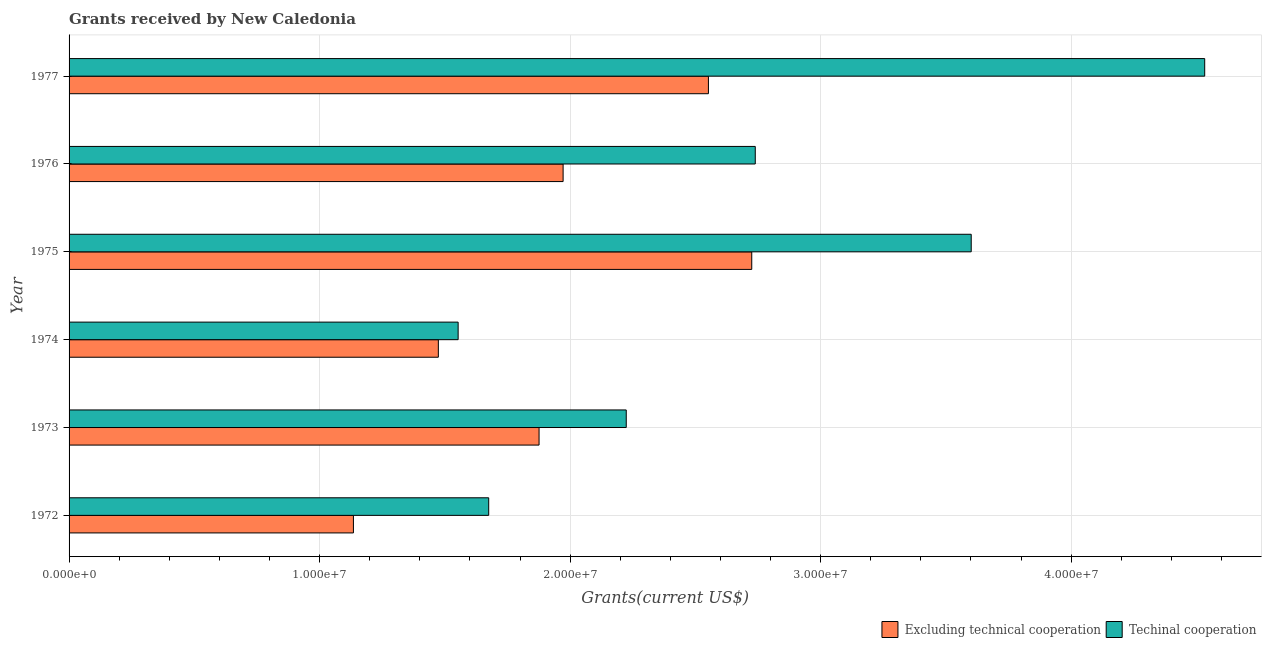How many groups of bars are there?
Your answer should be very brief. 6. Are the number of bars per tick equal to the number of legend labels?
Offer a very short reply. Yes. How many bars are there on the 3rd tick from the top?
Offer a terse response. 2. What is the label of the 4th group of bars from the top?
Your answer should be very brief. 1974. What is the amount of grants received(excluding technical cooperation) in 1972?
Your response must be concise. 1.14e+07. Across all years, what is the maximum amount of grants received(excluding technical cooperation)?
Make the answer very short. 2.72e+07. Across all years, what is the minimum amount of grants received(excluding technical cooperation)?
Your answer should be very brief. 1.14e+07. In which year was the amount of grants received(excluding technical cooperation) maximum?
Your answer should be compact. 1975. What is the total amount of grants received(including technical cooperation) in the graph?
Offer a very short reply. 1.63e+08. What is the difference between the amount of grants received(including technical cooperation) in 1973 and that in 1975?
Make the answer very short. -1.38e+07. What is the difference between the amount of grants received(excluding technical cooperation) in 1975 and the amount of grants received(including technical cooperation) in 1976?
Your response must be concise. -1.40e+05. What is the average amount of grants received(excluding technical cooperation) per year?
Your answer should be compact. 1.96e+07. In the year 1973, what is the difference between the amount of grants received(excluding technical cooperation) and amount of grants received(including technical cooperation)?
Give a very brief answer. -3.48e+06. In how many years, is the amount of grants received(excluding technical cooperation) greater than 2000000 US$?
Offer a terse response. 6. What is the ratio of the amount of grants received(including technical cooperation) in 1972 to that in 1974?
Make the answer very short. 1.08. Is the amount of grants received(excluding technical cooperation) in 1973 less than that in 1977?
Your answer should be very brief. Yes. What is the difference between the highest and the second highest amount of grants received(including technical cooperation)?
Offer a terse response. 9.32e+06. What is the difference between the highest and the lowest amount of grants received(excluding technical cooperation)?
Your response must be concise. 1.59e+07. Is the sum of the amount of grants received(excluding technical cooperation) in 1973 and 1975 greater than the maximum amount of grants received(including technical cooperation) across all years?
Provide a succinct answer. Yes. What does the 1st bar from the top in 1977 represents?
Provide a succinct answer. Techinal cooperation. What does the 1st bar from the bottom in 1976 represents?
Your answer should be compact. Excluding technical cooperation. How many years are there in the graph?
Provide a short and direct response. 6. Are the values on the major ticks of X-axis written in scientific E-notation?
Your answer should be compact. Yes. Does the graph contain any zero values?
Offer a terse response. No. Does the graph contain grids?
Make the answer very short. Yes. Where does the legend appear in the graph?
Offer a very short reply. Bottom right. How are the legend labels stacked?
Offer a very short reply. Horizontal. What is the title of the graph?
Give a very brief answer. Grants received by New Caledonia. Does "Primary education" appear as one of the legend labels in the graph?
Your answer should be compact. No. What is the label or title of the X-axis?
Provide a succinct answer. Grants(current US$). What is the Grants(current US$) in Excluding technical cooperation in 1972?
Offer a very short reply. 1.14e+07. What is the Grants(current US$) in Techinal cooperation in 1972?
Offer a terse response. 1.68e+07. What is the Grants(current US$) of Excluding technical cooperation in 1973?
Ensure brevity in your answer.  1.88e+07. What is the Grants(current US$) of Techinal cooperation in 1973?
Keep it short and to the point. 2.22e+07. What is the Grants(current US$) of Excluding technical cooperation in 1974?
Ensure brevity in your answer.  1.47e+07. What is the Grants(current US$) of Techinal cooperation in 1974?
Offer a very short reply. 1.55e+07. What is the Grants(current US$) in Excluding technical cooperation in 1975?
Make the answer very short. 2.72e+07. What is the Grants(current US$) in Techinal cooperation in 1975?
Make the answer very short. 3.60e+07. What is the Grants(current US$) in Excluding technical cooperation in 1976?
Give a very brief answer. 1.97e+07. What is the Grants(current US$) in Techinal cooperation in 1976?
Your answer should be compact. 2.74e+07. What is the Grants(current US$) of Excluding technical cooperation in 1977?
Make the answer very short. 2.55e+07. What is the Grants(current US$) in Techinal cooperation in 1977?
Give a very brief answer. 4.53e+07. Across all years, what is the maximum Grants(current US$) of Excluding technical cooperation?
Offer a terse response. 2.72e+07. Across all years, what is the maximum Grants(current US$) in Techinal cooperation?
Your response must be concise. 4.53e+07. Across all years, what is the minimum Grants(current US$) of Excluding technical cooperation?
Provide a short and direct response. 1.14e+07. Across all years, what is the minimum Grants(current US$) in Techinal cooperation?
Keep it short and to the point. 1.55e+07. What is the total Grants(current US$) of Excluding technical cooperation in the graph?
Your answer should be compact. 1.17e+08. What is the total Grants(current US$) of Techinal cooperation in the graph?
Ensure brevity in your answer.  1.63e+08. What is the difference between the Grants(current US$) of Excluding technical cooperation in 1972 and that in 1973?
Provide a short and direct response. -7.41e+06. What is the difference between the Grants(current US$) in Techinal cooperation in 1972 and that in 1973?
Your response must be concise. -5.49e+06. What is the difference between the Grants(current US$) in Excluding technical cooperation in 1972 and that in 1974?
Your answer should be compact. -3.39e+06. What is the difference between the Grants(current US$) of Techinal cooperation in 1972 and that in 1974?
Give a very brief answer. 1.22e+06. What is the difference between the Grants(current US$) of Excluding technical cooperation in 1972 and that in 1975?
Your response must be concise. -1.59e+07. What is the difference between the Grants(current US$) of Techinal cooperation in 1972 and that in 1975?
Make the answer very short. -1.93e+07. What is the difference between the Grants(current US$) in Excluding technical cooperation in 1972 and that in 1976?
Provide a short and direct response. -8.37e+06. What is the difference between the Grants(current US$) of Techinal cooperation in 1972 and that in 1976?
Offer a terse response. -1.06e+07. What is the difference between the Grants(current US$) in Excluding technical cooperation in 1972 and that in 1977?
Give a very brief answer. -1.42e+07. What is the difference between the Grants(current US$) in Techinal cooperation in 1972 and that in 1977?
Make the answer very short. -2.86e+07. What is the difference between the Grants(current US$) of Excluding technical cooperation in 1973 and that in 1974?
Ensure brevity in your answer.  4.02e+06. What is the difference between the Grants(current US$) of Techinal cooperation in 1973 and that in 1974?
Give a very brief answer. 6.71e+06. What is the difference between the Grants(current US$) of Excluding technical cooperation in 1973 and that in 1975?
Make the answer very short. -8.49e+06. What is the difference between the Grants(current US$) of Techinal cooperation in 1973 and that in 1975?
Your answer should be very brief. -1.38e+07. What is the difference between the Grants(current US$) of Excluding technical cooperation in 1973 and that in 1976?
Ensure brevity in your answer.  -9.60e+05. What is the difference between the Grants(current US$) of Techinal cooperation in 1973 and that in 1976?
Offer a very short reply. -5.15e+06. What is the difference between the Grants(current US$) in Excluding technical cooperation in 1973 and that in 1977?
Your response must be concise. -6.76e+06. What is the difference between the Grants(current US$) of Techinal cooperation in 1973 and that in 1977?
Keep it short and to the point. -2.31e+07. What is the difference between the Grants(current US$) in Excluding technical cooperation in 1974 and that in 1975?
Your response must be concise. -1.25e+07. What is the difference between the Grants(current US$) in Techinal cooperation in 1974 and that in 1975?
Offer a very short reply. -2.05e+07. What is the difference between the Grants(current US$) of Excluding technical cooperation in 1974 and that in 1976?
Make the answer very short. -4.98e+06. What is the difference between the Grants(current US$) in Techinal cooperation in 1974 and that in 1976?
Your answer should be compact. -1.19e+07. What is the difference between the Grants(current US$) in Excluding technical cooperation in 1974 and that in 1977?
Provide a short and direct response. -1.08e+07. What is the difference between the Grants(current US$) in Techinal cooperation in 1974 and that in 1977?
Provide a short and direct response. -2.98e+07. What is the difference between the Grants(current US$) of Excluding technical cooperation in 1975 and that in 1976?
Provide a succinct answer. 7.53e+06. What is the difference between the Grants(current US$) of Techinal cooperation in 1975 and that in 1976?
Your answer should be very brief. 8.62e+06. What is the difference between the Grants(current US$) in Excluding technical cooperation in 1975 and that in 1977?
Offer a terse response. 1.73e+06. What is the difference between the Grants(current US$) in Techinal cooperation in 1975 and that in 1977?
Provide a short and direct response. -9.32e+06. What is the difference between the Grants(current US$) in Excluding technical cooperation in 1976 and that in 1977?
Your response must be concise. -5.80e+06. What is the difference between the Grants(current US$) in Techinal cooperation in 1976 and that in 1977?
Offer a very short reply. -1.79e+07. What is the difference between the Grants(current US$) in Excluding technical cooperation in 1972 and the Grants(current US$) in Techinal cooperation in 1973?
Your answer should be very brief. -1.09e+07. What is the difference between the Grants(current US$) of Excluding technical cooperation in 1972 and the Grants(current US$) of Techinal cooperation in 1974?
Provide a short and direct response. -4.18e+06. What is the difference between the Grants(current US$) of Excluding technical cooperation in 1972 and the Grants(current US$) of Techinal cooperation in 1975?
Offer a very short reply. -2.47e+07. What is the difference between the Grants(current US$) of Excluding technical cooperation in 1972 and the Grants(current US$) of Techinal cooperation in 1976?
Ensure brevity in your answer.  -1.60e+07. What is the difference between the Grants(current US$) of Excluding technical cooperation in 1972 and the Grants(current US$) of Techinal cooperation in 1977?
Offer a terse response. -3.40e+07. What is the difference between the Grants(current US$) of Excluding technical cooperation in 1973 and the Grants(current US$) of Techinal cooperation in 1974?
Your answer should be very brief. 3.23e+06. What is the difference between the Grants(current US$) in Excluding technical cooperation in 1973 and the Grants(current US$) in Techinal cooperation in 1975?
Your answer should be compact. -1.72e+07. What is the difference between the Grants(current US$) in Excluding technical cooperation in 1973 and the Grants(current US$) in Techinal cooperation in 1976?
Offer a terse response. -8.63e+06. What is the difference between the Grants(current US$) in Excluding technical cooperation in 1973 and the Grants(current US$) in Techinal cooperation in 1977?
Keep it short and to the point. -2.66e+07. What is the difference between the Grants(current US$) of Excluding technical cooperation in 1974 and the Grants(current US$) of Techinal cooperation in 1975?
Your answer should be very brief. -2.13e+07. What is the difference between the Grants(current US$) of Excluding technical cooperation in 1974 and the Grants(current US$) of Techinal cooperation in 1976?
Your answer should be very brief. -1.26e+07. What is the difference between the Grants(current US$) in Excluding technical cooperation in 1974 and the Grants(current US$) in Techinal cooperation in 1977?
Offer a very short reply. -3.06e+07. What is the difference between the Grants(current US$) of Excluding technical cooperation in 1975 and the Grants(current US$) of Techinal cooperation in 1976?
Your answer should be compact. -1.40e+05. What is the difference between the Grants(current US$) of Excluding technical cooperation in 1975 and the Grants(current US$) of Techinal cooperation in 1977?
Make the answer very short. -1.81e+07. What is the difference between the Grants(current US$) of Excluding technical cooperation in 1976 and the Grants(current US$) of Techinal cooperation in 1977?
Provide a short and direct response. -2.56e+07. What is the average Grants(current US$) of Excluding technical cooperation per year?
Make the answer very short. 1.96e+07. What is the average Grants(current US$) of Techinal cooperation per year?
Offer a terse response. 2.72e+07. In the year 1972, what is the difference between the Grants(current US$) in Excluding technical cooperation and Grants(current US$) in Techinal cooperation?
Ensure brevity in your answer.  -5.40e+06. In the year 1973, what is the difference between the Grants(current US$) of Excluding technical cooperation and Grants(current US$) of Techinal cooperation?
Offer a very short reply. -3.48e+06. In the year 1974, what is the difference between the Grants(current US$) in Excluding technical cooperation and Grants(current US$) in Techinal cooperation?
Provide a succinct answer. -7.90e+05. In the year 1975, what is the difference between the Grants(current US$) of Excluding technical cooperation and Grants(current US$) of Techinal cooperation?
Provide a short and direct response. -8.76e+06. In the year 1976, what is the difference between the Grants(current US$) in Excluding technical cooperation and Grants(current US$) in Techinal cooperation?
Your answer should be compact. -7.67e+06. In the year 1977, what is the difference between the Grants(current US$) of Excluding technical cooperation and Grants(current US$) of Techinal cooperation?
Provide a succinct answer. -1.98e+07. What is the ratio of the Grants(current US$) of Excluding technical cooperation in 1972 to that in 1973?
Give a very brief answer. 0.6. What is the ratio of the Grants(current US$) in Techinal cooperation in 1972 to that in 1973?
Your answer should be very brief. 0.75. What is the ratio of the Grants(current US$) of Excluding technical cooperation in 1972 to that in 1974?
Ensure brevity in your answer.  0.77. What is the ratio of the Grants(current US$) of Techinal cooperation in 1972 to that in 1974?
Make the answer very short. 1.08. What is the ratio of the Grants(current US$) in Excluding technical cooperation in 1972 to that in 1975?
Offer a terse response. 0.42. What is the ratio of the Grants(current US$) of Techinal cooperation in 1972 to that in 1975?
Keep it short and to the point. 0.47. What is the ratio of the Grants(current US$) in Excluding technical cooperation in 1972 to that in 1976?
Your response must be concise. 0.58. What is the ratio of the Grants(current US$) of Techinal cooperation in 1972 to that in 1976?
Offer a very short reply. 0.61. What is the ratio of the Grants(current US$) in Excluding technical cooperation in 1972 to that in 1977?
Provide a short and direct response. 0.44. What is the ratio of the Grants(current US$) in Techinal cooperation in 1972 to that in 1977?
Keep it short and to the point. 0.37. What is the ratio of the Grants(current US$) in Excluding technical cooperation in 1973 to that in 1974?
Your answer should be very brief. 1.27. What is the ratio of the Grants(current US$) in Techinal cooperation in 1973 to that in 1974?
Provide a succinct answer. 1.43. What is the ratio of the Grants(current US$) in Excluding technical cooperation in 1973 to that in 1975?
Offer a terse response. 0.69. What is the ratio of the Grants(current US$) in Techinal cooperation in 1973 to that in 1975?
Provide a short and direct response. 0.62. What is the ratio of the Grants(current US$) of Excluding technical cooperation in 1973 to that in 1976?
Your answer should be very brief. 0.95. What is the ratio of the Grants(current US$) of Techinal cooperation in 1973 to that in 1976?
Your response must be concise. 0.81. What is the ratio of the Grants(current US$) of Excluding technical cooperation in 1973 to that in 1977?
Make the answer very short. 0.74. What is the ratio of the Grants(current US$) of Techinal cooperation in 1973 to that in 1977?
Provide a short and direct response. 0.49. What is the ratio of the Grants(current US$) of Excluding technical cooperation in 1974 to that in 1975?
Your response must be concise. 0.54. What is the ratio of the Grants(current US$) in Techinal cooperation in 1974 to that in 1975?
Ensure brevity in your answer.  0.43. What is the ratio of the Grants(current US$) in Excluding technical cooperation in 1974 to that in 1976?
Offer a terse response. 0.75. What is the ratio of the Grants(current US$) of Techinal cooperation in 1974 to that in 1976?
Your answer should be compact. 0.57. What is the ratio of the Grants(current US$) in Excluding technical cooperation in 1974 to that in 1977?
Make the answer very short. 0.58. What is the ratio of the Grants(current US$) in Techinal cooperation in 1974 to that in 1977?
Give a very brief answer. 0.34. What is the ratio of the Grants(current US$) in Excluding technical cooperation in 1975 to that in 1976?
Give a very brief answer. 1.38. What is the ratio of the Grants(current US$) of Techinal cooperation in 1975 to that in 1976?
Your answer should be very brief. 1.31. What is the ratio of the Grants(current US$) of Excluding technical cooperation in 1975 to that in 1977?
Your answer should be compact. 1.07. What is the ratio of the Grants(current US$) in Techinal cooperation in 1975 to that in 1977?
Keep it short and to the point. 0.79. What is the ratio of the Grants(current US$) of Excluding technical cooperation in 1976 to that in 1977?
Keep it short and to the point. 0.77. What is the ratio of the Grants(current US$) in Techinal cooperation in 1976 to that in 1977?
Keep it short and to the point. 0.6. What is the difference between the highest and the second highest Grants(current US$) of Excluding technical cooperation?
Your answer should be very brief. 1.73e+06. What is the difference between the highest and the second highest Grants(current US$) in Techinal cooperation?
Your answer should be very brief. 9.32e+06. What is the difference between the highest and the lowest Grants(current US$) in Excluding technical cooperation?
Your response must be concise. 1.59e+07. What is the difference between the highest and the lowest Grants(current US$) in Techinal cooperation?
Ensure brevity in your answer.  2.98e+07. 